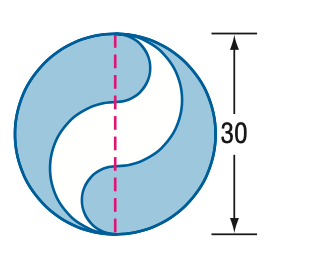Is this type of problem typical in geometry education? Yes, this type of problem is quite typical in geometry education. It helps students practice and understand the properties of circles, the concept of π, and complex area calculations by combining different shapes. Such problems are valuable for developing spatial reasoning and problem-solving skills. 